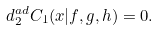<formula> <loc_0><loc_0><loc_500><loc_500>d _ { 2 } ^ { a d } C _ { 1 } ( x | f , g , h ) = 0 .</formula> 